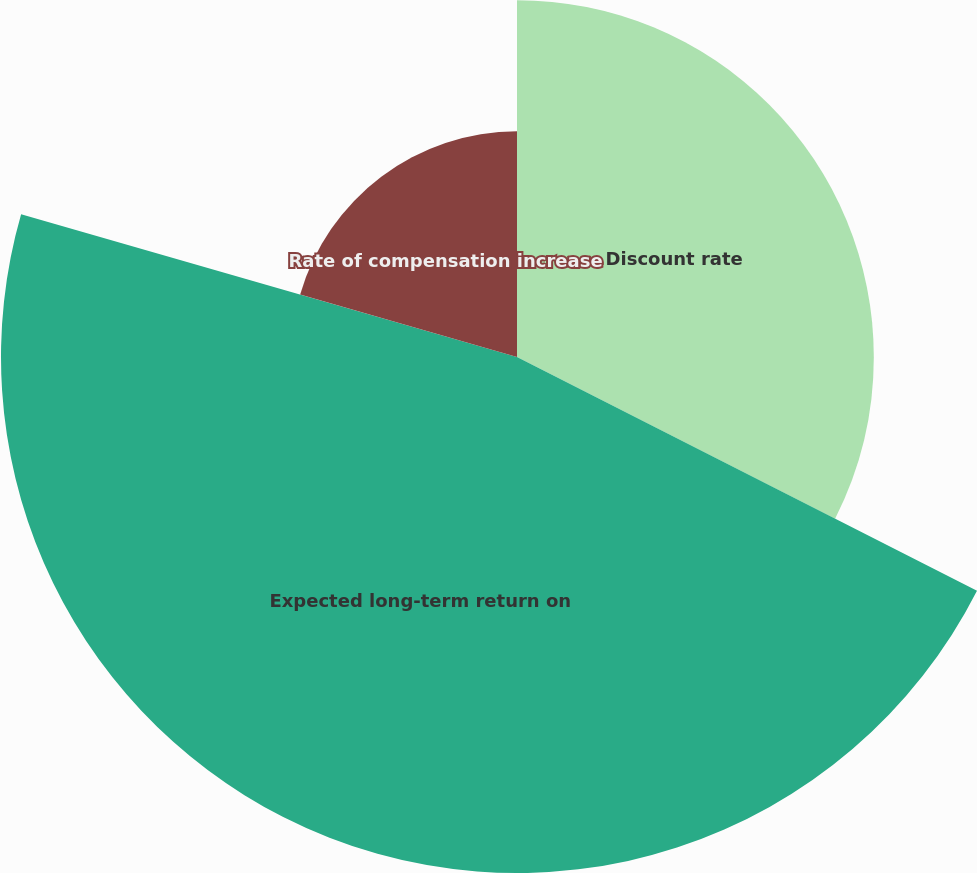Convert chart. <chart><loc_0><loc_0><loc_500><loc_500><pie_chart><fcel>Discount rate<fcel>Expected long-term return on<fcel>Rate of compensation increase<nl><fcel>32.48%<fcel>46.97%<fcel>20.54%<nl></chart> 